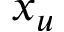<formula> <loc_0><loc_0><loc_500><loc_500>x _ { u }</formula> 